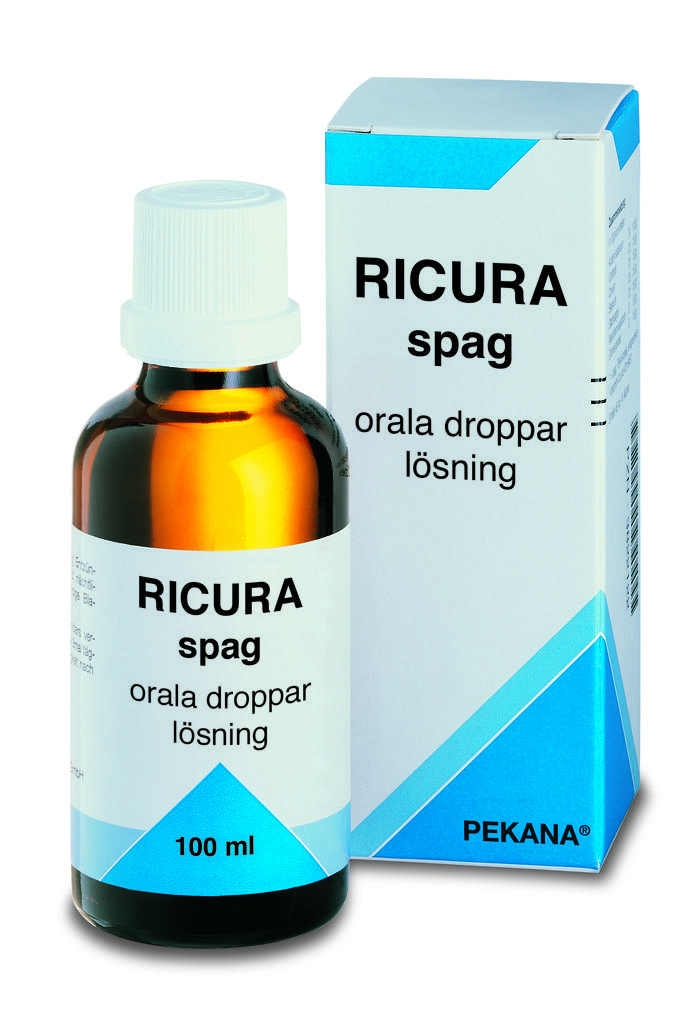What company makes this medication?
Keep it short and to the point. Pekana. What is the ml on the bottle?
Keep it short and to the point. 100. 